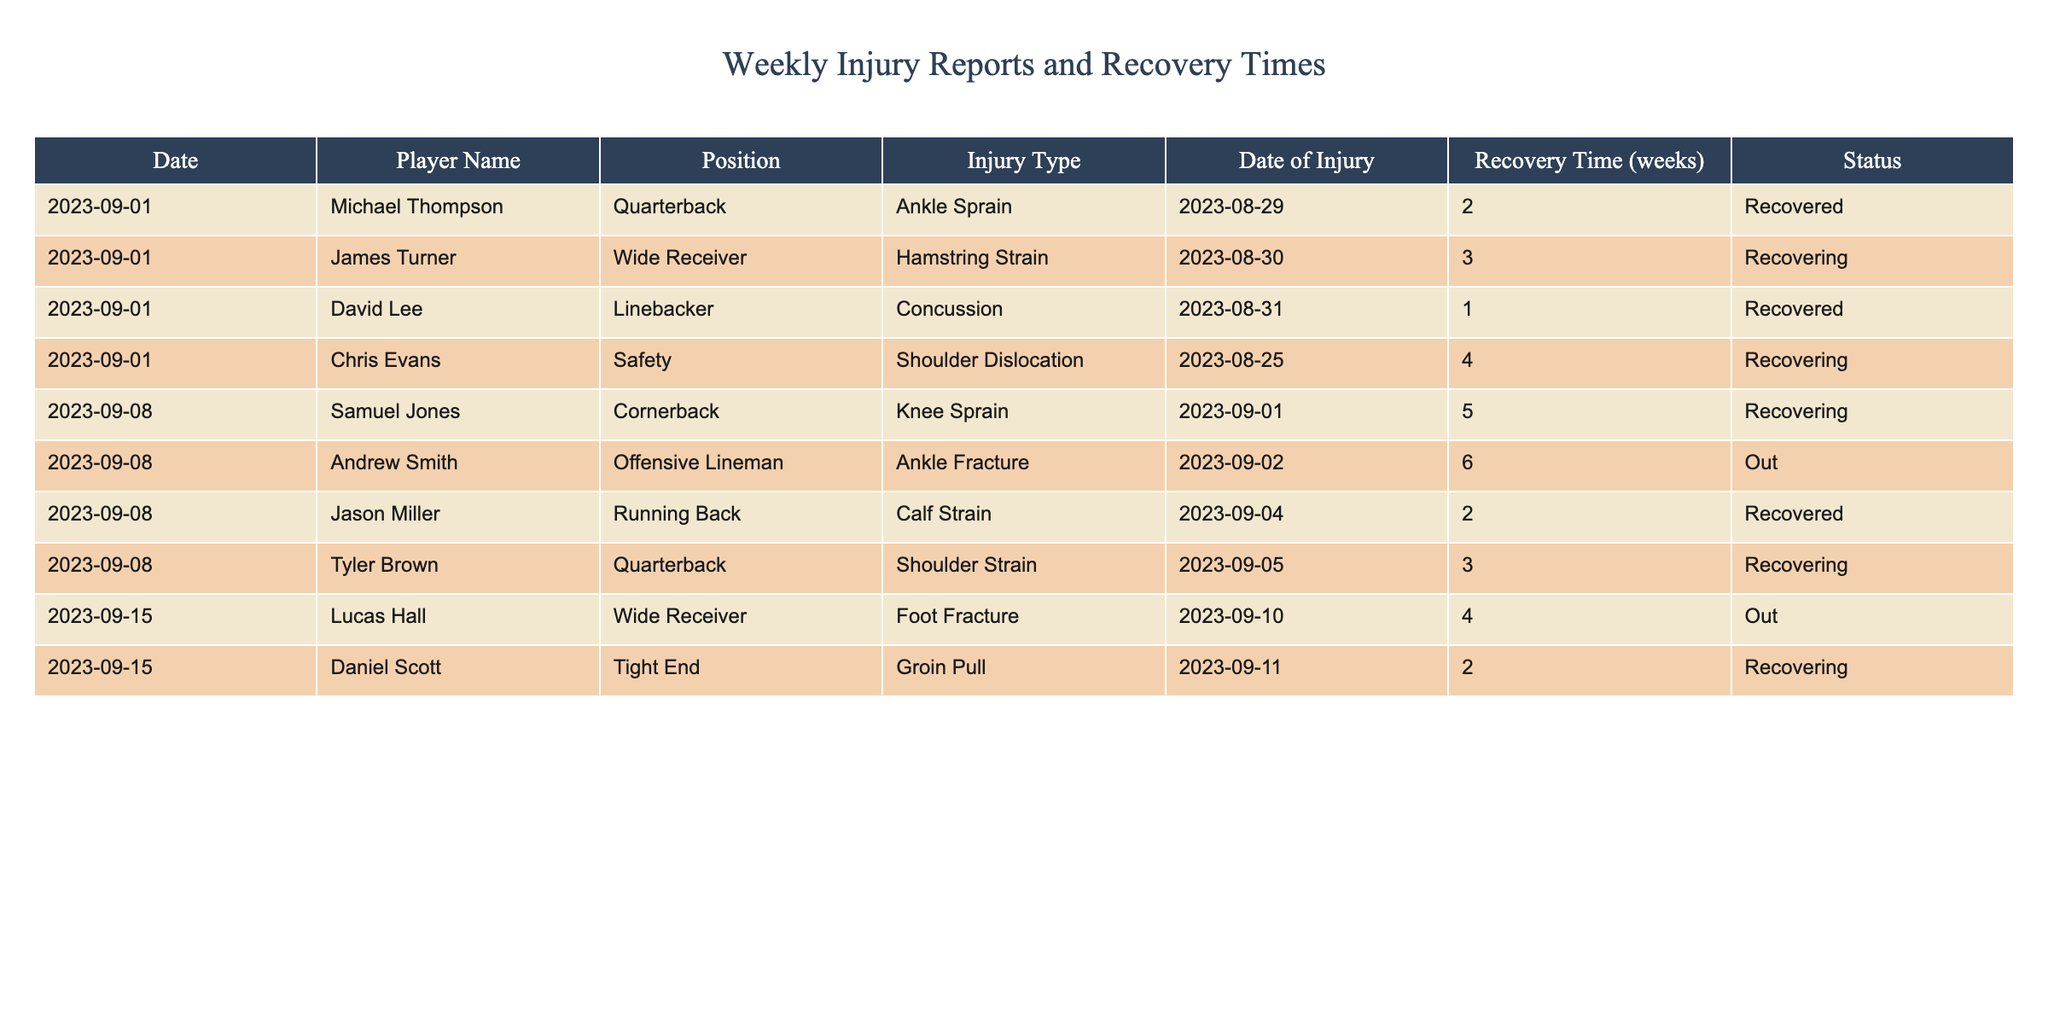What is the injury type of Michael Thompson? Michael Thompson's details are listed in the table under the "Player Name" column, and his corresponding "Injury Type" is "Ankle Sprain."
Answer: Ankle Sprain How many weeks is Chris Evans expected to recover? According to the status report, Chris Evans has a recovery time of 4 weeks listed under the "Recovery Time (weeks)" column.
Answer: 4 weeks Is Andrew Smith fully recovered from his injury? The status for Andrew Smith is "Out," indicating that he is not recovered and is still unable to participate.
Answer: No Which player has the longest recovery time, and what is that time? By comparing the "Recovery Time (weeks)" for all players, Andrew Smith has the longest recovery time of 6 weeks due to an "Ankle Fracture."
Answer: Andrew Smith, 6 weeks What is the total recovery time for players currently recovering? The recovery times for players currently recovering are James Turner (3 weeks), Chris Evans (4 weeks), Tyler Brown (3 weeks), and Daniel Scott (2 weeks). Summing these values (3 + 4 + 3 + 2) gives a total of 12 weeks.
Answer: 12 weeks Are there any players recovering from a concussion? Checking the table, David Lee is listed with a concussion but his status shows he has already recovered. Thus, no players are currently recovering from a concussion.
Answer: No Which player has a foot fracture and what is their recovery status? The table lists Lucas Hall as having a "Foot Fracture," and his current status is "Out," meaning he is not recovering yet.
Answer: Lucas Hall, Out How many players are listed as recovered? By counting the players with the status of "Recovered," we find that there are 3 players: Michael Thompson, David Lee, and Jason Miller.
Answer: 3 players What is the status of the player with the shoulder strain? Tyler Brown has a "Shoulder Strain" and is currently in the status of "Recovering."
Answer: Recovering 